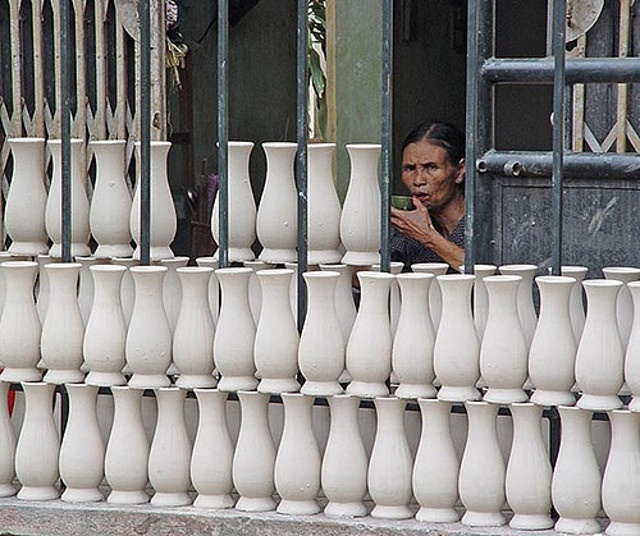Describe the objects in this image and their specific colors. I can see vase in black, lightgray, darkgray, and gray tones, people in black, gray, maroon, and brown tones, vase in black, lightgray, and darkgray tones, vase in black, lightgray, darkgray, and gray tones, and vase in black, lightgray, and darkgray tones in this image. 